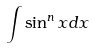Convert formula to latex. <formula><loc_0><loc_0><loc_500><loc_500>\int \sin ^ { n } x d x</formula> 